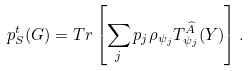<formula> <loc_0><loc_0><loc_500><loc_500>p _ { S } ^ { t } ( G ) = T r \left [ \sum _ { j } p _ { j } \rho _ { \psi _ { j } } T _ { \psi _ { j } } ^ { \widehat { A } } ( Y ) \right ] .</formula> 